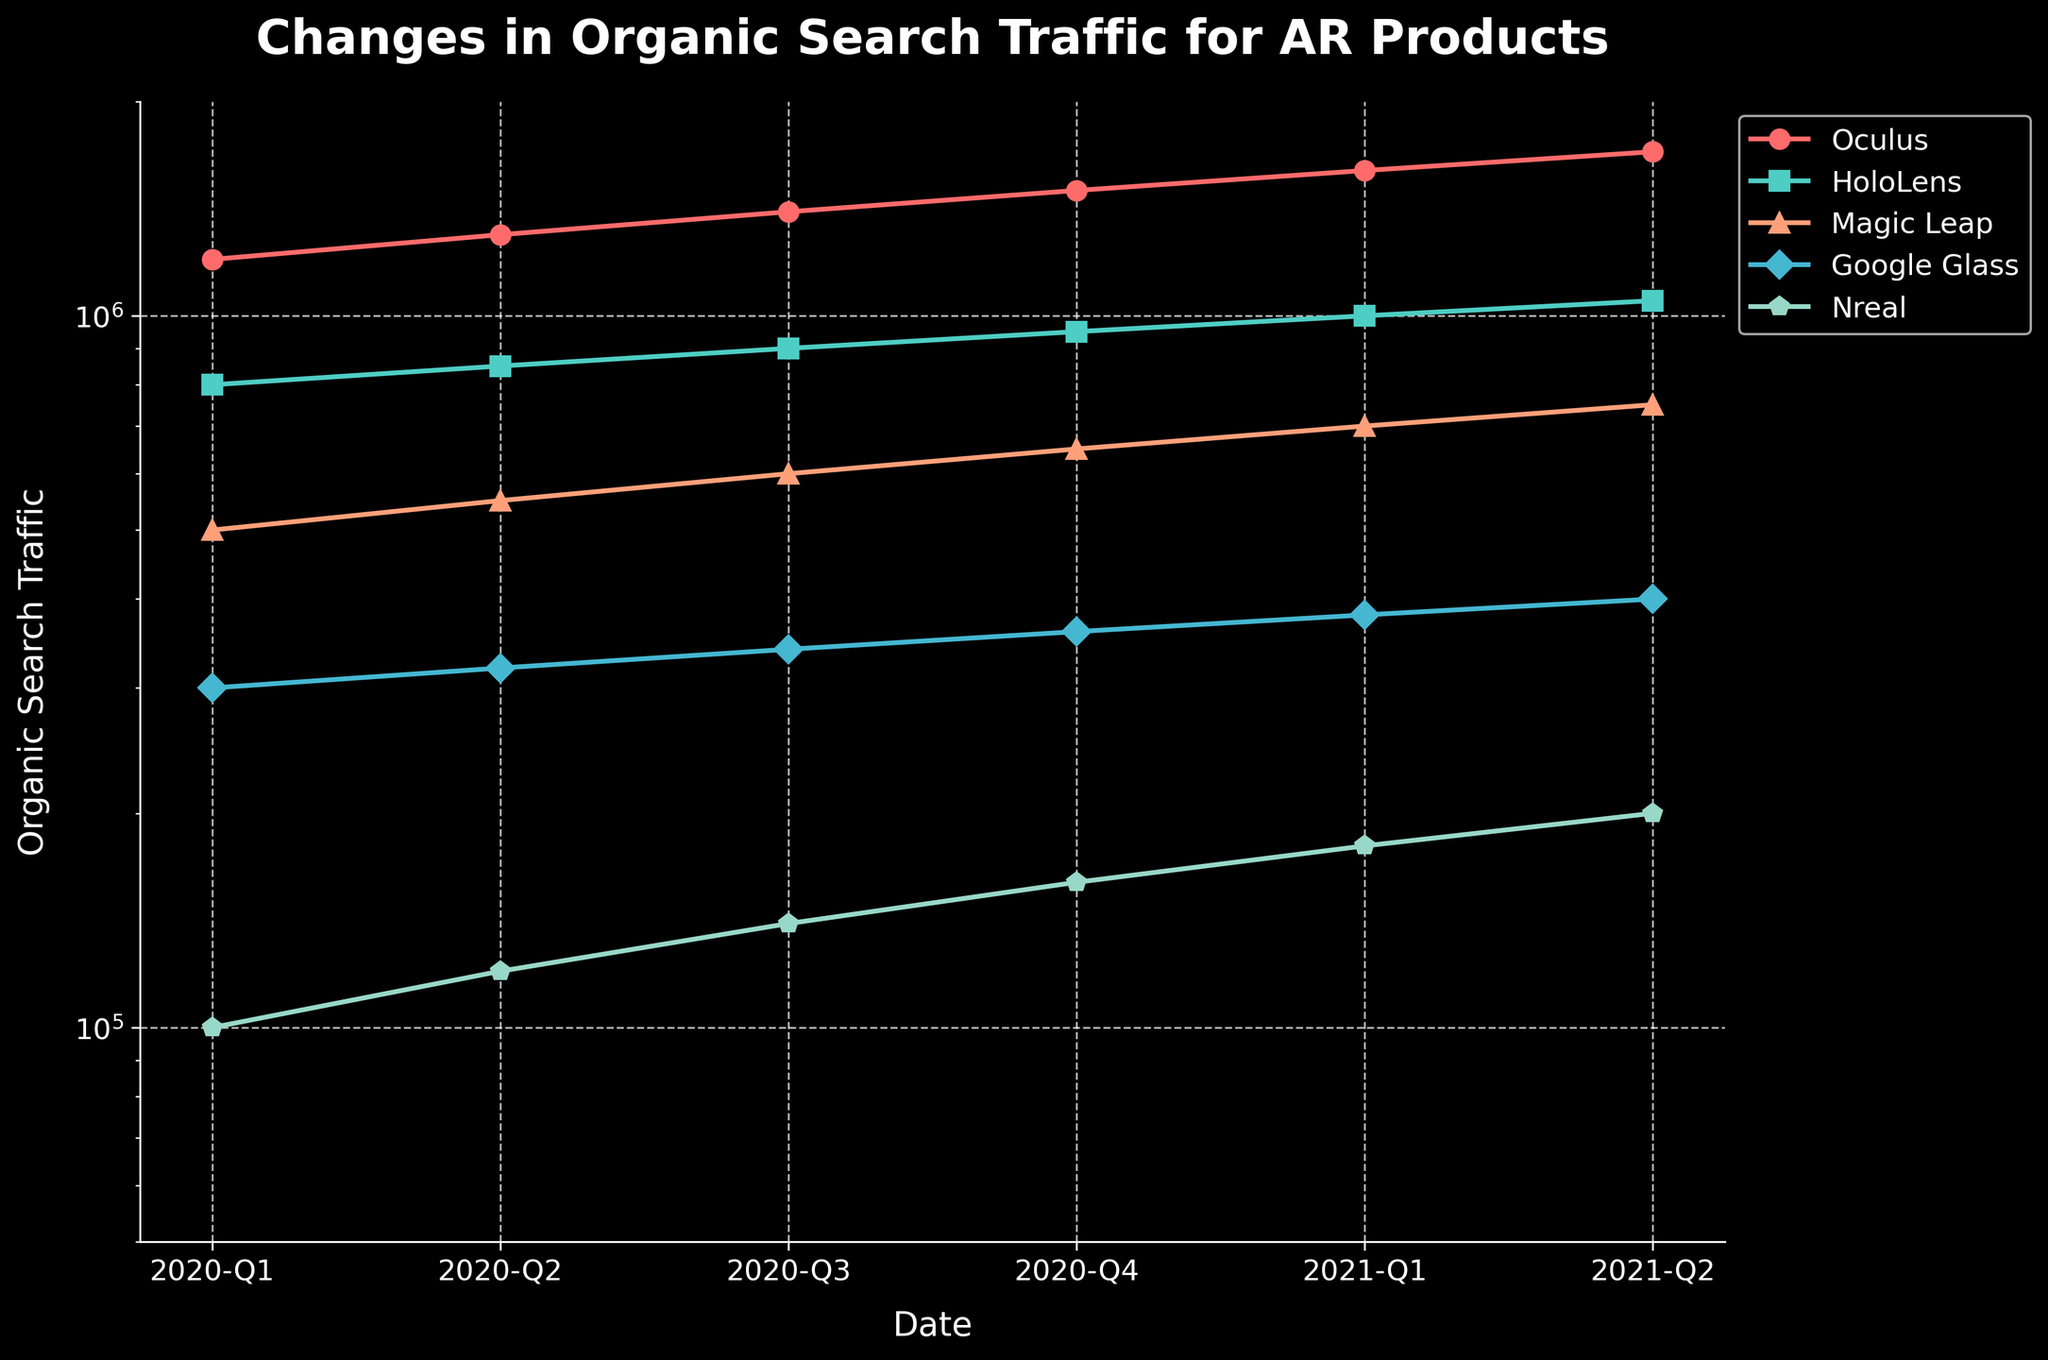What product shows the highest increase in organic search traffic from Q1 2020 to Q2 2021? To find the highest increase, we need to calculate the difference between Q2 2021 and Q1 2020 for each product. Oculus: 1700000 - 1200000 = 500000, HoloLens: 1050000 - 800000 = 250000, Magic Leap: 750000 - 500000 = 250000, Google Glass: 400000 - 300000 = 100000, Nreal: 200000 - 100000 = 100000. Oculus has the highest increase.
Answer: Oculus Which product had the lowest organic search traffic in Q1 2020? By looking at the data for Q1 2020 for organic search traffic, the values for each product are: Oculus: 1200000, HoloLens: 800000, Magic Leap: 500000, Google Glass: 300000, Nreal: 100000. The lowest value is for Nreal.
Answer: Nreal Comparing Q3 2020 and Q3 2021, did the traffic for HoloLens increase or decrease, and by how much? First, we need to find the values for HoloLens in Q3 2020 and 2021. In Q3 2020, it was 900000. In Q3 2021, it is not given, but using Q2 2021 as approximation (1050000). The difference is 1050000 - 900000 = 150000, showing an increase.
Answer: Increase by 150000 What is the percentage increase in organic search traffic for Magic Leap from Q1 2021 to Q2 2021? The values for Magic Leap in Q1 2021 and Q2 2021 are 700000 and 750000 respectively. The percentage increase is calculated as ((750000 - 700000) / 700000) * 100 = (50000 / 700000) * 100 ≈ 7.14%.
Answer: 7.14% Which product had the largest fluctuation in organic search traffic between the displayed quarters? We need to look at the range (max - min) of the organic search traffic for each product. Oculus: 1700000 - 1200000 = 500000, HoloLens: 1050000 - 800000 = 250000, Magic Leap: 750000 - 500000 = 250000, Google Glass: 400000 - 300000 = 100000, Nreal: 200000 - 100000 = 100000. The largest range is for Oculus.
Answer: Oculus During which quarter did Google Glass see its highest organic search traffic? To identify the highest traffic, we review the organic search values for each quarter. Q1 2020: 300000, Q2 2020: 320000, Q3 2020: 340000, Q4 2020: 360000, Q1 2021: 380000, Q2 2021: 400000. The highest traffic is in Q2 2021.
Answer: Q2 2021 Is there any quarter where all products had an increase in organic search traffic compared to the previous quarter? Review each product's quarter-to-quarter change for the provided data. Q2 2020: All values increased compared to Q1 2020. No other quarter has all products increasing.
Answer: Q2 2020 